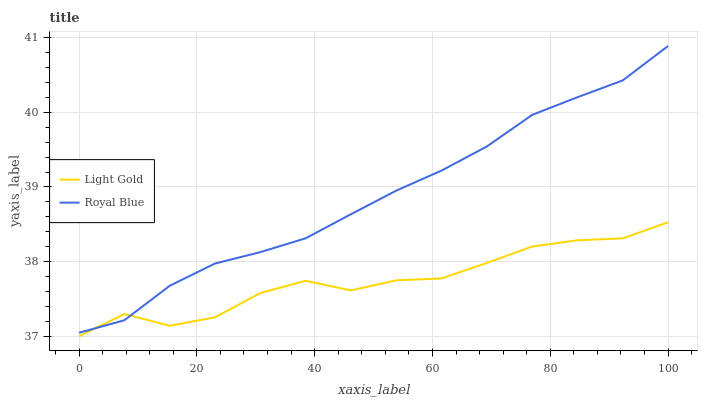Does Light Gold have the minimum area under the curve?
Answer yes or no. Yes. Does Royal Blue have the maximum area under the curve?
Answer yes or no. Yes. Does Light Gold have the maximum area under the curve?
Answer yes or no. No. Is Royal Blue the smoothest?
Answer yes or no. Yes. Is Light Gold the roughest?
Answer yes or no. Yes. Is Light Gold the smoothest?
Answer yes or no. No. Does Light Gold have the lowest value?
Answer yes or no. Yes. Does Royal Blue have the highest value?
Answer yes or no. Yes. Does Light Gold have the highest value?
Answer yes or no. No. Does Light Gold intersect Royal Blue?
Answer yes or no. Yes. Is Light Gold less than Royal Blue?
Answer yes or no. No. Is Light Gold greater than Royal Blue?
Answer yes or no. No. 